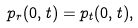Convert formula to latex. <formula><loc_0><loc_0><loc_500><loc_500>p _ { r } ( 0 , t ) = p _ { t } ( 0 , t ) ,</formula> 